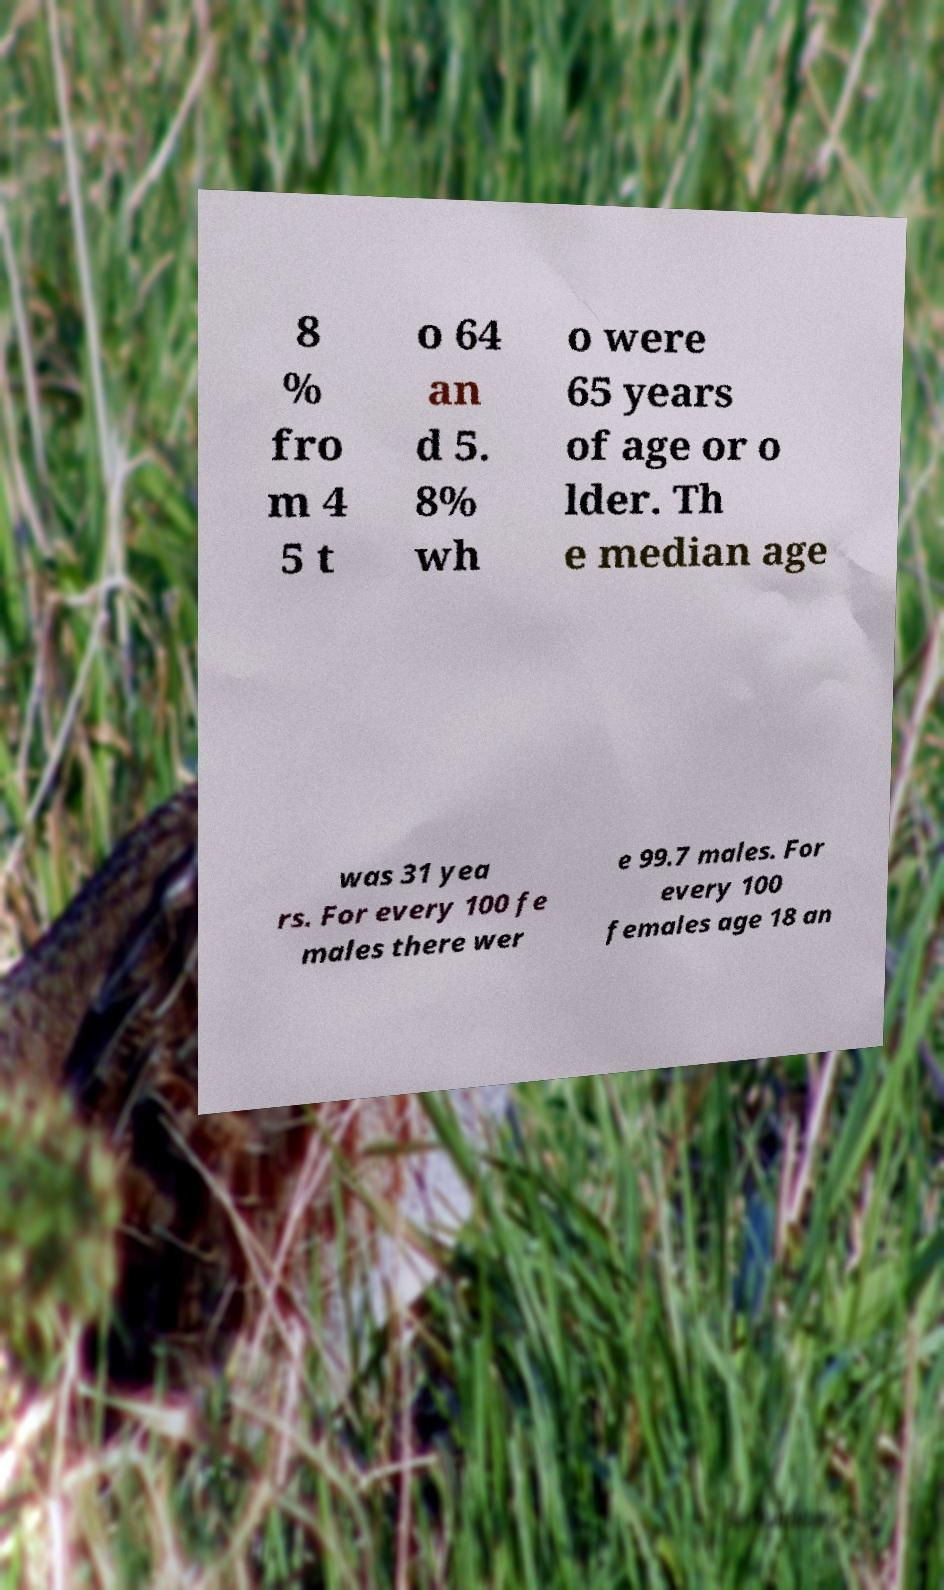Could you extract and type out the text from this image? 8 % fro m 4 5 t o 64 an d 5. 8% wh o were 65 years of age or o lder. Th e median age was 31 yea rs. For every 100 fe males there wer e 99.7 males. For every 100 females age 18 an 